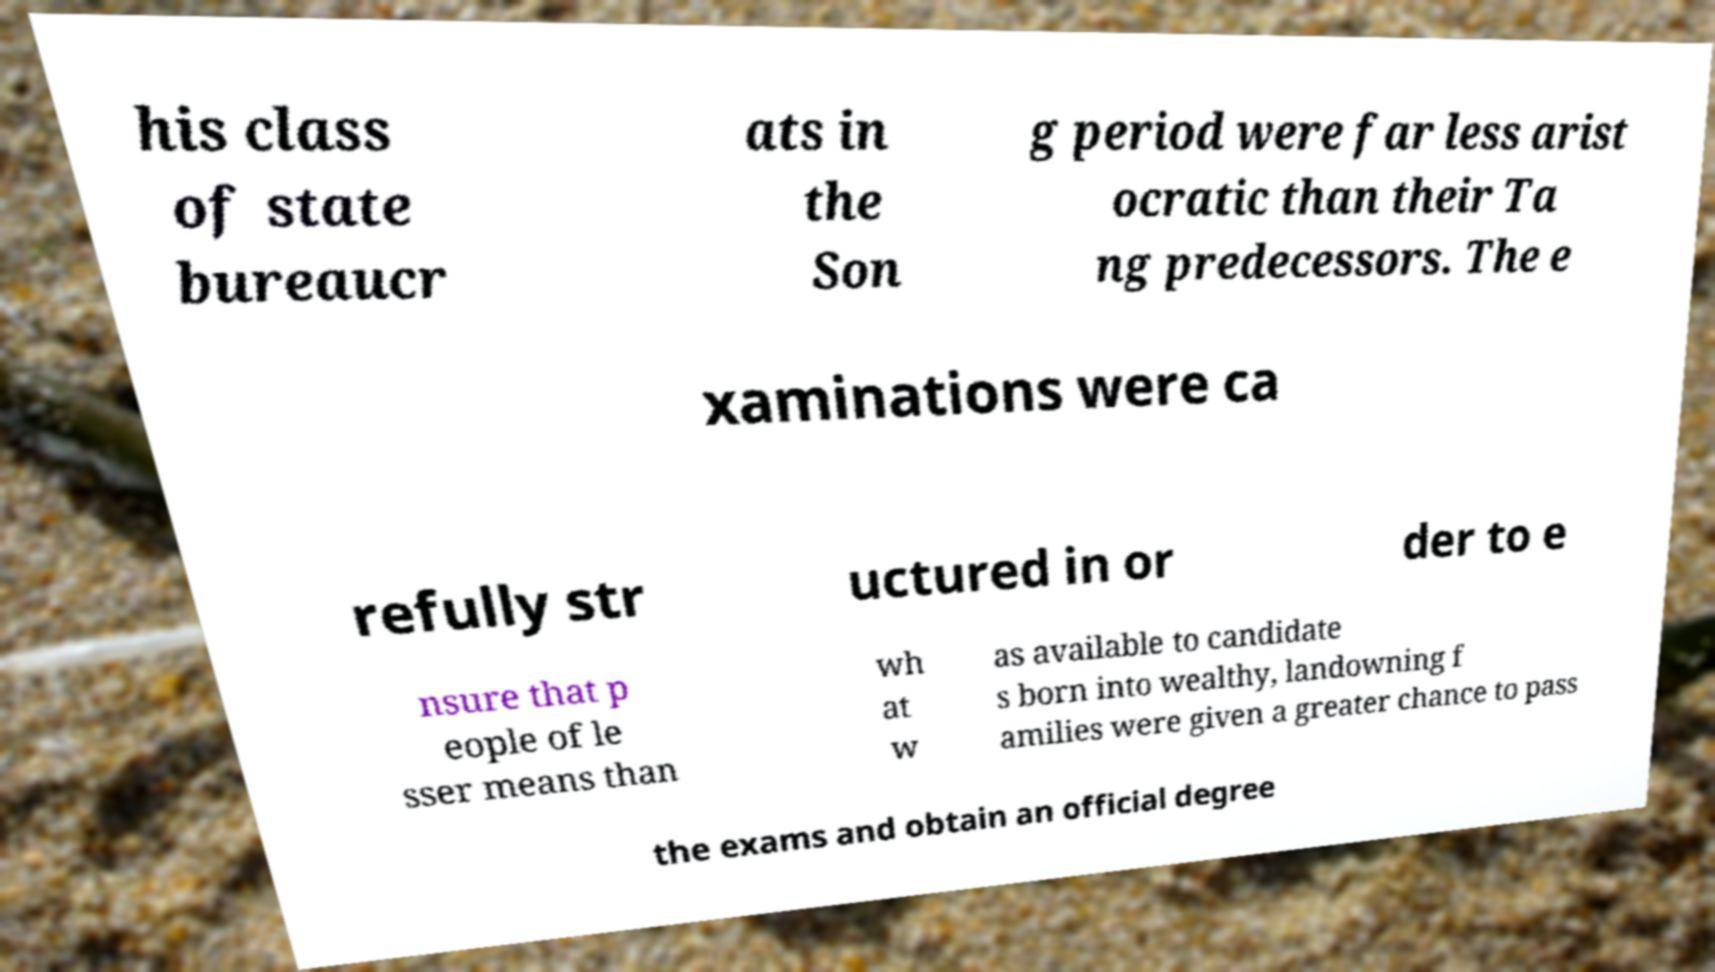For documentation purposes, I need the text within this image transcribed. Could you provide that? his class of state bureaucr ats in the Son g period were far less arist ocratic than their Ta ng predecessors. The e xaminations were ca refully str uctured in or der to e nsure that p eople of le sser means than wh at w as available to candidate s born into wealthy, landowning f amilies were given a greater chance to pass the exams and obtain an official degree 